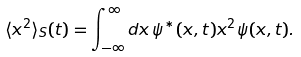<formula> <loc_0><loc_0><loc_500><loc_500>\langle x ^ { 2 } \rangle _ { S } ( t ) = \int _ { - \infty } ^ { \infty } d x \, \psi ^ { * } ( x , t ) x ^ { 2 } \psi ( x , t ) .</formula> 